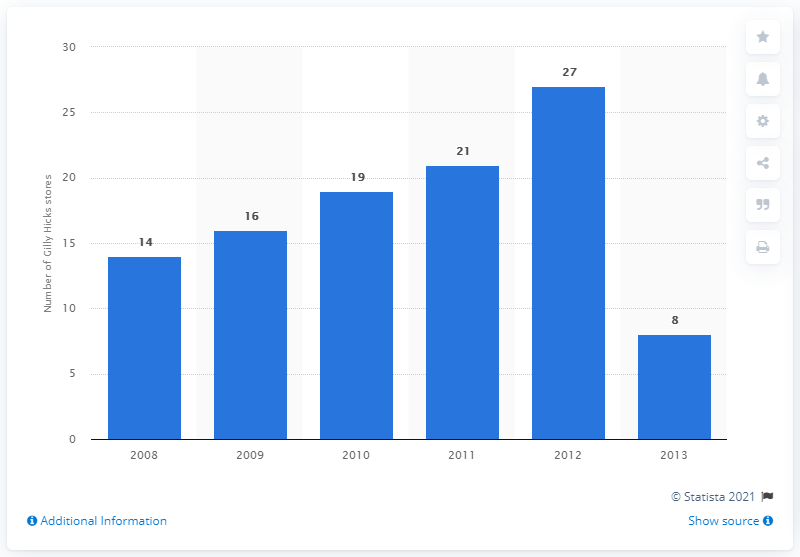List a handful of essential elements in this visual. In 2011, Abercrombie & Fitch operated a total of 21 Gilly Hicks stores. 